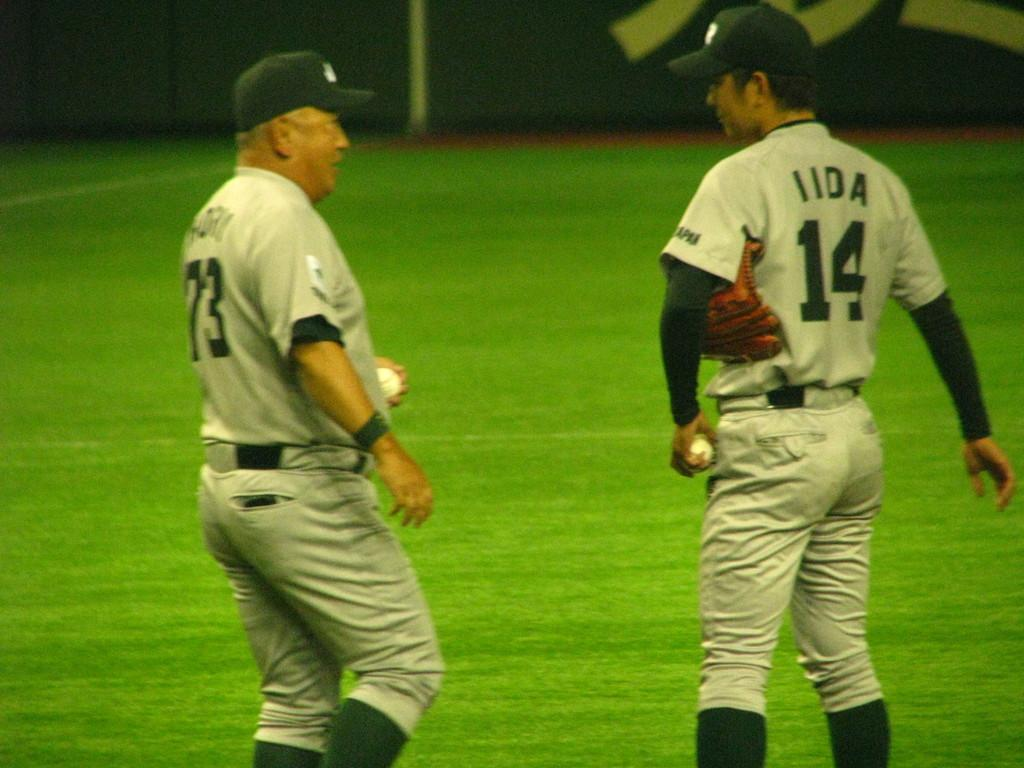<image>
Relay a brief, clear account of the picture shown. Player 14 is talking to player 73 on the field. 